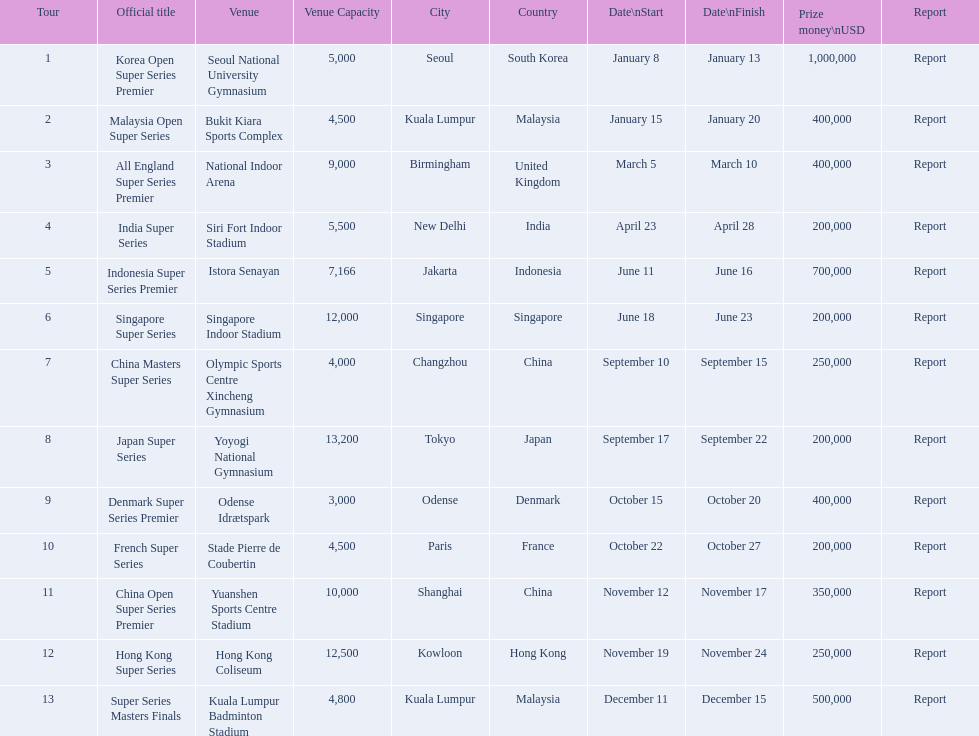What were the titles of the 2013 bwf super series? Korea Open Super Series Premier, Malaysia Open Super Series, All England Super Series Premier, India Super Series, Indonesia Super Series Premier, Singapore Super Series, China Masters Super Series, Japan Super Series, Denmark Super Series Premier, French Super Series, China Open Super Series Premier, Hong Kong Super Series, Super Series Masters Finals. Which were in december? Super Series Masters Finals. 